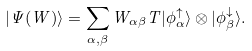<formula> <loc_0><loc_0><loc_500><loc_500>| \Psi ( W ) \rangle = \sum _ { \alpha , \beta } W _ { \alpha \beta } { T } | \phi ^ { \uparrow } _ { \alpha } \rangle \otimes | \phi ^ { \downarrow } _ { \beta } \rangle .</formula> 